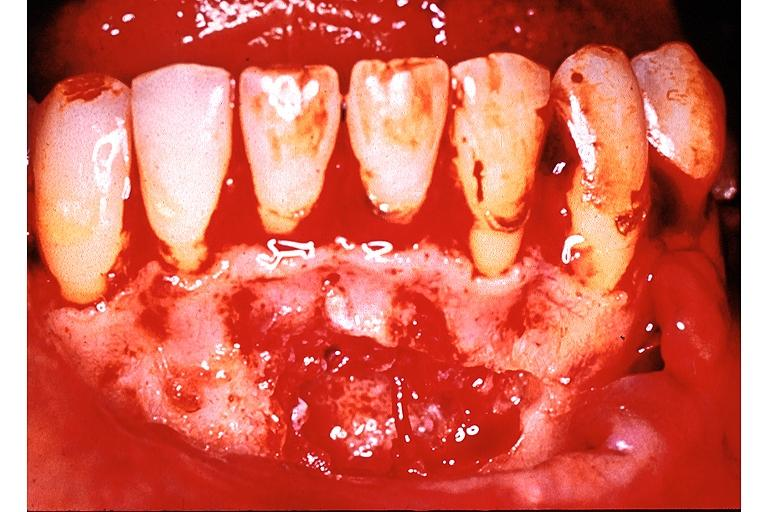what does this image show?
Answer the question using a single word or phrase. Traumatic bone cyst simple bone cyst 